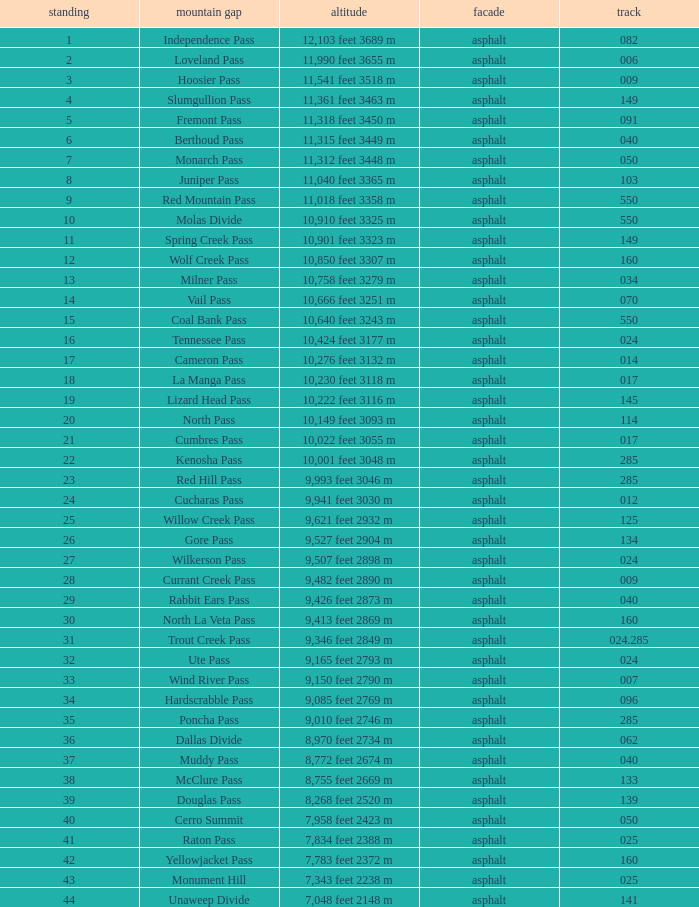On what Route is the mountain with a Rank less than 33 and an Elevation of 11,312 feet 3448 m? 50.0. Would you mind parsing the complete table? {'header': ['standing', 'mountain gap', 'altitude', 'facade', 'track'], 'rows': [['1', 'Independence Pass', '12,103 feet 3689 m', 'asphalt', '082'], ['2', 'Loveland Pass', '11,990 feet 3655 m', 'asphalt', '006'], ['3', 'Hoosier Pass', '11,541 feet 3518 m', 'asphalt', '009'], ['4', 'Slumgullion Pass', '11,361 feet 3463 m', 'asphalt', '149'], ['5', 'Fremont Pass', '11,318 feet 3450 m', 'asphalt', '091'], ['6', 'Berthoud Pass', '11,315 feet 3449 m', 'asphalt', '040'], ['7', 'Monarch Pass', '11,312 feet 3448 m', 'asphalt', '050'], ['8', 'Juniper Pass', '11,040 feet 3365 m', 'asphalt', '103'], ['9', 'Red Mountain Pass', '11,018 feet 3358 m', 'asphalt', '550'], ['10', 'Molas Divide', '10,910 feet 3325 m', 'asphalt', '550'], ['11', 'Spring Creek Pass', '10,901 feet 3323 m', 'asphalt', '149'], ['12', 'Wolf Creek Pass', '10,850 feet 3307 m', 'asphalt', '160'], ['13', 'Milner Pass', '10,758 feet 3279 m', 'asphalt', '034'], ['14', 'Vail Pass', '10,666 feet 3251 m', 'asphalt', '070'], ['15', 'Coal Bank Pass', '10,640 feet 3243 m', 'asphalt', '550'], ['16', 'Tennessee Pass', '10,424 feet 3177 m', 'asphalt', '024'], ['17', 'Cameron Pass', '10,276 feet 3132 m', 'asphalt', '014'], ['18', 'La Manga Pass', '10,230 feet 3118 m', 'asphalt', '017'], ['19', 'Lizard Head Pass', '10,222 feet 3116 m', 'asphalt', '145'], ['20', 'North Pass', '10,149 feet 3093 m', 'asphalt', '114'], ['21', 'Cumbres Pass', '10,022 feet 3055 m', 'asphalt', '017'], ['22', 'Kenosha Pass', '10,001 feet 3048 m', 'asphalt', '285'], ['23', 'Red Hill Pass', '9,993 feet 3046 m', 'asphalt', '285'], ['24', 'Cucharas Pass', '9,941 feet 3030 m', 'asphalt', '012'], ['25', 'Willow Creek Pass', '9,621 feet 2932 m', 'asphalt', '125'], ['26', 'Gore Pass', '9,527 feet 2904 m', 'asphalt', '134'], ['27', 'Wilkerson Pass', '9,507 feet 2898 m', 'asphalt', '024'], ['28', 'Currant Creek Pass', '9,482 feet 2890 m', 'asphalt', '009'], ['29', 'Rabbit Ears Pass', '9,426 feet 2873 m', 'asphalt', '040'], ['30', 'North La Veta Pass', '9,413 feet 2869 m', 'asphalt', '160'], ['31', 'Trout Creek Pass', '9,346 feet 2849 m', 'asphalt', '024.285'], ['32', 'Ute Pass', '9,165 feet 2793 m', 'asphalt', '024'], ['33', 'Wind River Pass', '9,150 feet 2790 m', 'asphalt', '007'], ['34', 'Hardscrabble Pass', '9,085 feet 2769 m', 'asphalt', '096'], ['35', 'Poncha Pass', '9,010 feet 2746 m', 'asphalt', '285'], ['36', 'Dallas Divide', '8,970 feet 2734 m', 'asphalt', '062'], ['37', 'Muddy Pass', '8,772 feet 2674 m', 'asphalt', '040'], ['38', 'McClure Pass', '8,755 feet 2669 m', 'asphalt', '133'], ['39', 'Douglas Pass', '8,268 feet 2520 m', 'asphalt', '139'], ['40', 'Cerro Summit', '7,958 feet 2423 m', 'asphalt', '050'], ['41', 'Raton Pass', '7,834 feet 2388 m', 'asphalt', '025'], ['42', 'Yellowjacket Pass', '7,783 feet 2372 m', 'asphalt', '160'], ['43', 'Monument Hill', '7,343 feet 2238 m', 'asphalt', '025'], ['44', 'Unaweep Divide', '7,048 feet 2148 m', 'asphalt', '141']]} 